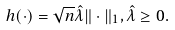Convert formula to latex. <formula><loc_0><loc_0><loc_500><loc_500>h ( \cdot ) = \sqrt { n } \hat { \lambda } \| \cdot \| _ { 1 } , \hat { \lambda } \geq 0 .</formula> 